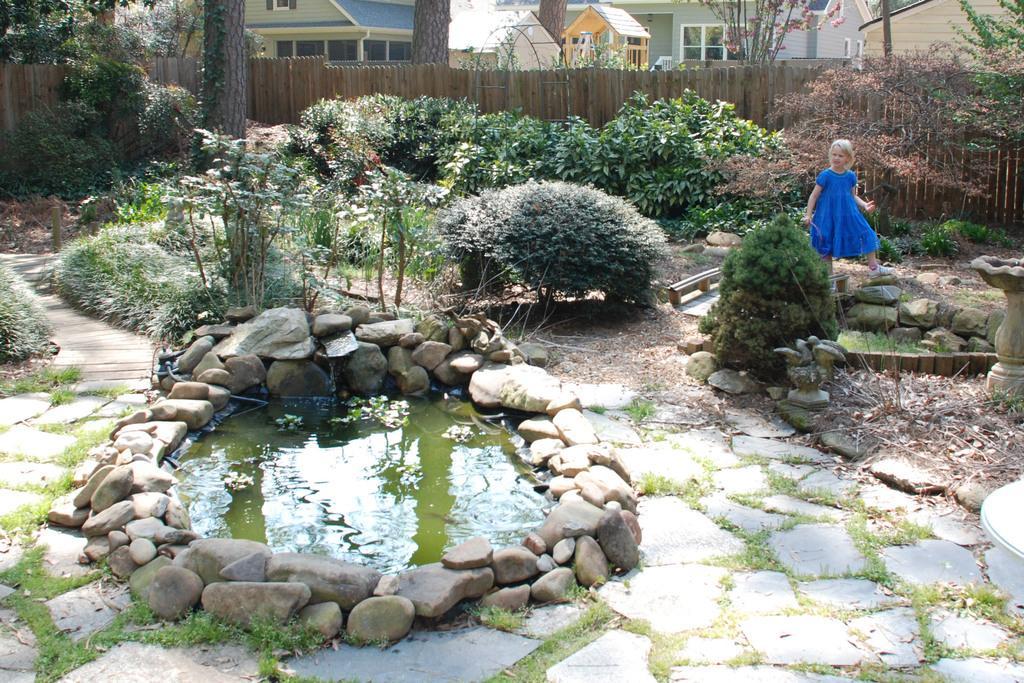Could you give a brief overview of what you see in this image? In this image we can see a girl, water, rocks, pedestal, grass, plants, fence, and trees. In the background there are houses. 